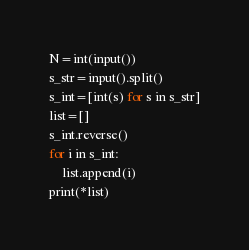<code> <loc_0><loc_0><loc_500><loc_500><_Python_>N=int(input())
s_str=input().split()
s_int=[int(s) for s in s_str]
list=[]
s_int.reverse()
for i in s_int:
    list.append(i)
print(*list)


</code> 